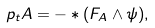Convert formula to latex. <formula><loc_0><loc_0><loc_500><loc_500>\ p _ { t } A = - * ( F _ { A } \wedge \psi ) ,</formula> 